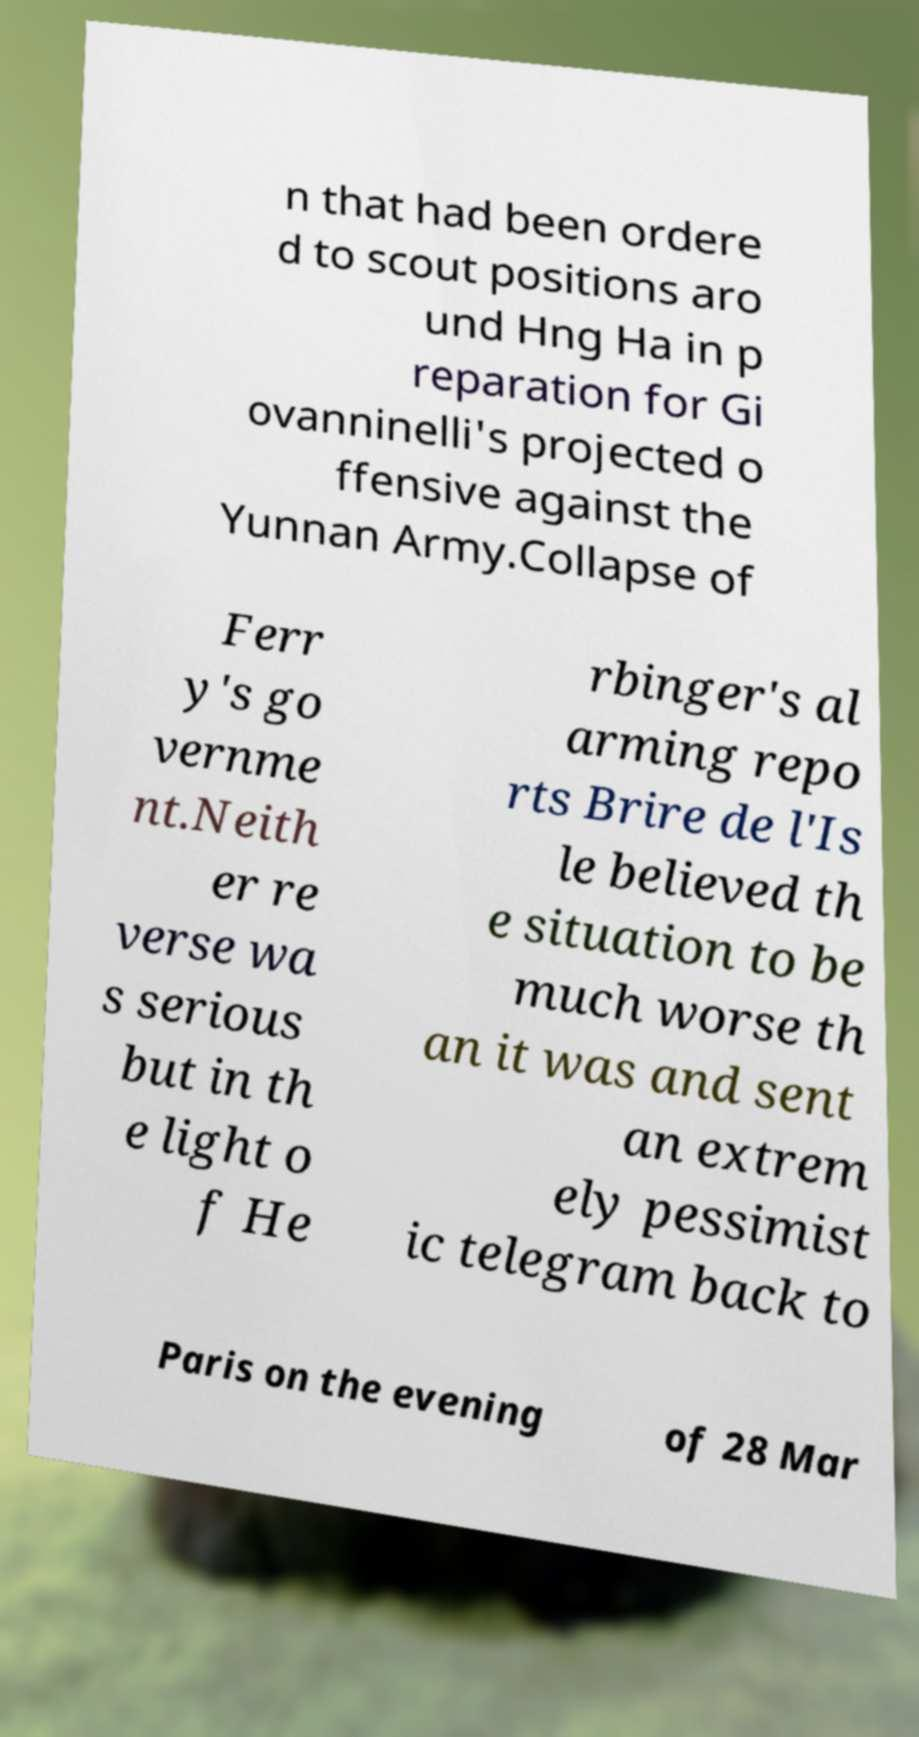There's text embedded in this image that I need extracted. Can you transcribe it verbatim? n that had been ordere d to scout positions aro und Hng Ha in p reparation for Gi ovanninelli's projected o ffensive against the Yunnan Army.Collapse of Ferr y's go vernme nt.Neith er re verse wa s serious but in th e light o f He rbinger's al arming repo rts Brire de l'Is le believed th e situation to be much worse th an it was and sent an extrem ely pessimist ic telegram back to Paris on the evening of 28 Mar 